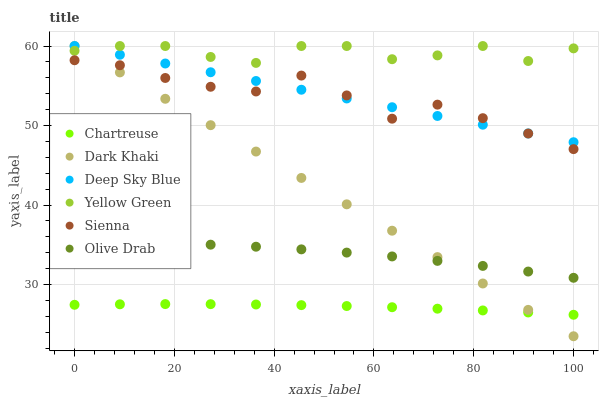Does Chartreuse have the minimum area under the curve?
Answer yes or no. Yes. Does Yellow Green have the maximum area under the curve?
Answer yes or no. Yes. Does Dark Khaki have the minimum area under the curve?
Answer yes or no. No. Does Dark Khaki have the maximum area under the curve?
Answer yes or no. No. Is Dark Khaki the smoothest?
Answer yes or no. Yes. Is Yellow Green the roughest?
Answer yes or no. Yes. Is Yellow Green the smoothest?
Answer yes or no. No. Is Dark Khaki the roughest?
Answer yes or no. No. Does Dark Khaki have the lowest value?
Answer yes or no. Yes. Does Yellow Green have the lowest value?
Answer yes or no. No. Does Deep Sky Blue have the highest value?
Answer yes or no. Yes. Does Chartreuse have the highest value?
Answer yes or no. No. Is Chartreuse less than Deep Sky Blue?
Answer yes or no. Yes. Is Yellow Green greater than Olive Drab?
Answer yes or no. Yes. Does Dark Khaki intersect Yellow Green?
Answer yes or no. Yes. Is Dark Khaki less than Yellow Green?
Answer yes or no. No. Is Dark Khaki greater than Yellow Green?
Answer yes or no. No. Does Chartreuse intersect Deep Sky Blue?
Answer yes or no. No. 